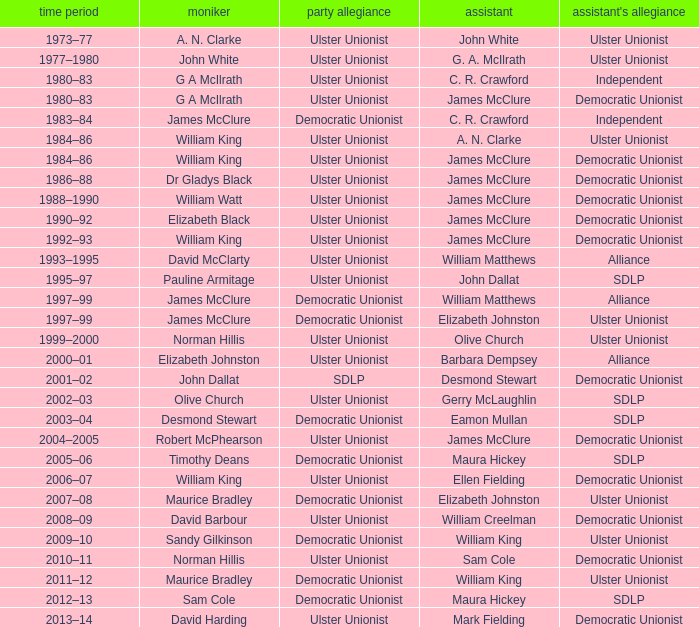What is the Deputy's affiliation in 1992–93? Democratic Unionist. 